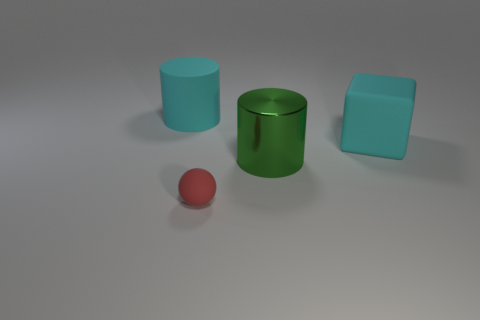Add 4 small red shiny cylinders. How many objects exist? 8 Subtract all cubes. How many objects are left? 3 Subtract all blue shiny spheres. Subtract all big blocks. How many objects are left? 3 Add 1 cubes. How many cubes are left? 2 Add 2 red things. How many red things exist? 3 Subtract 0 gray balls. How many objects are left? 4 